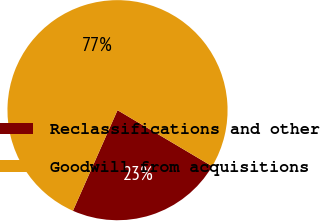Convert chart to OTSL. <chart><loc_0><loc_0><loc_500><loc_500><pie_chart><fcel>Reclassifications and other<fcel>Goodwill from acquisitions<nl><fcel>23.12%<fcel>76.88%<nl></chart> 